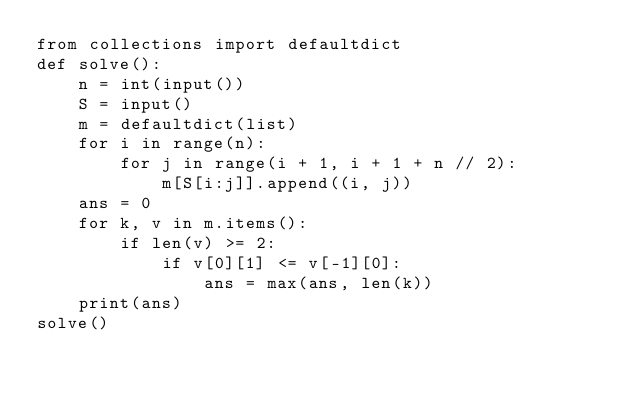Convert code to text. <code><loc_0><loc_0><loc_500><loc_500><_Python_>from collections import defaultdict
def solve():
    n = int(input())
    S = input()
    m = defaultdict(list)
    for i in range(n):
        for j in range(i + 1, i + 1 + n // 2):
            m[S[i:j]].append((i, j))
    ans = 0
    for k, v in m.items():
        if len(v) >= 2:
            if v[0][1] <= v[-1][0]:
                ans = max(ans, len(k))
    print(ans)
solve()
</code> 